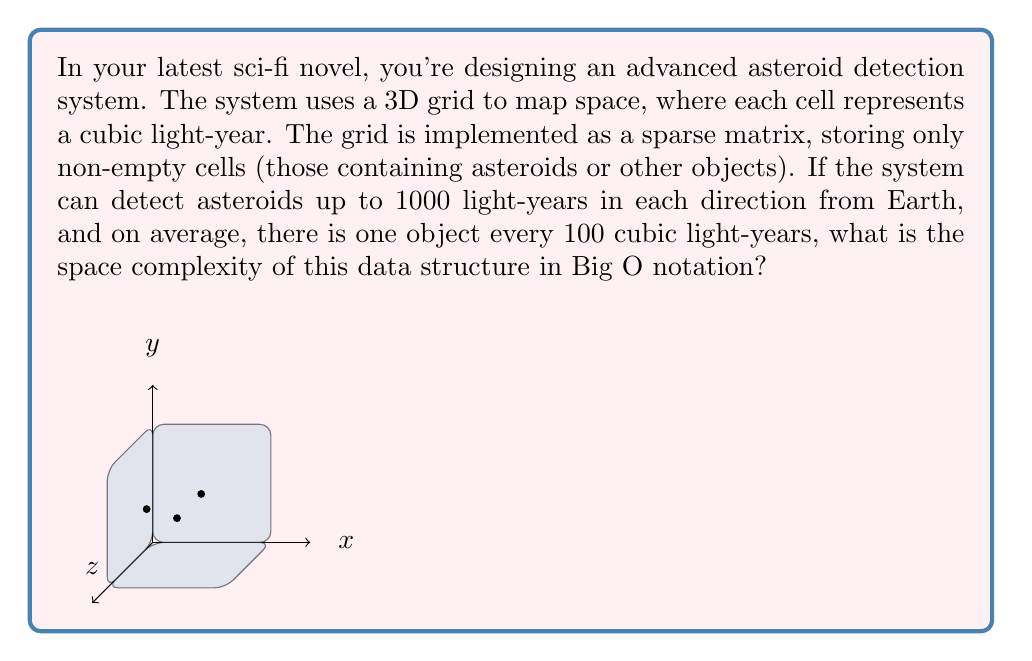Teach me how to tackle this problem. Let's approach this step-by-step:

1) First, we need to calculate the total volume of space being monitored:
   $$V = (2000)^3 = 8 \times 10^9$$ cubic light-years
   (1000 light-years in each direction from Earth, so 2000 light-years total in each dimension)

2) Now, we need to determine how many objects are in this volume on average:
   $$N = \frac{V}{100} = \frac{8 \times 10^9}{100} = 8 \times 10^7$$ objects

3) In a sparse matrix implementation, we only store non-empty cells. Each non-empty cell (object) requires storage for:
   - Its position (3 coordinates)
   - Any additional data about the object

4) Let's assume each piece of data (coordinate or object information) requires a constant amount of space, say $c$.

5) Therefore, the total space required is:
   $$S = N \times (3 + 1) \times c = 4cN = 4c \times 8 \times 10^7 = 32c \times 10^7$$

6) In Big O notation, we drop constant factors and focus on the growth rate. The space complexity grows linearly with the number of objects $N$.

7) Therefore, the space complexity is $O(N)$, where $N$ is the number of objects in the monitored space.
Answer: $O(N)$, where $N$ is the number of objects detected 